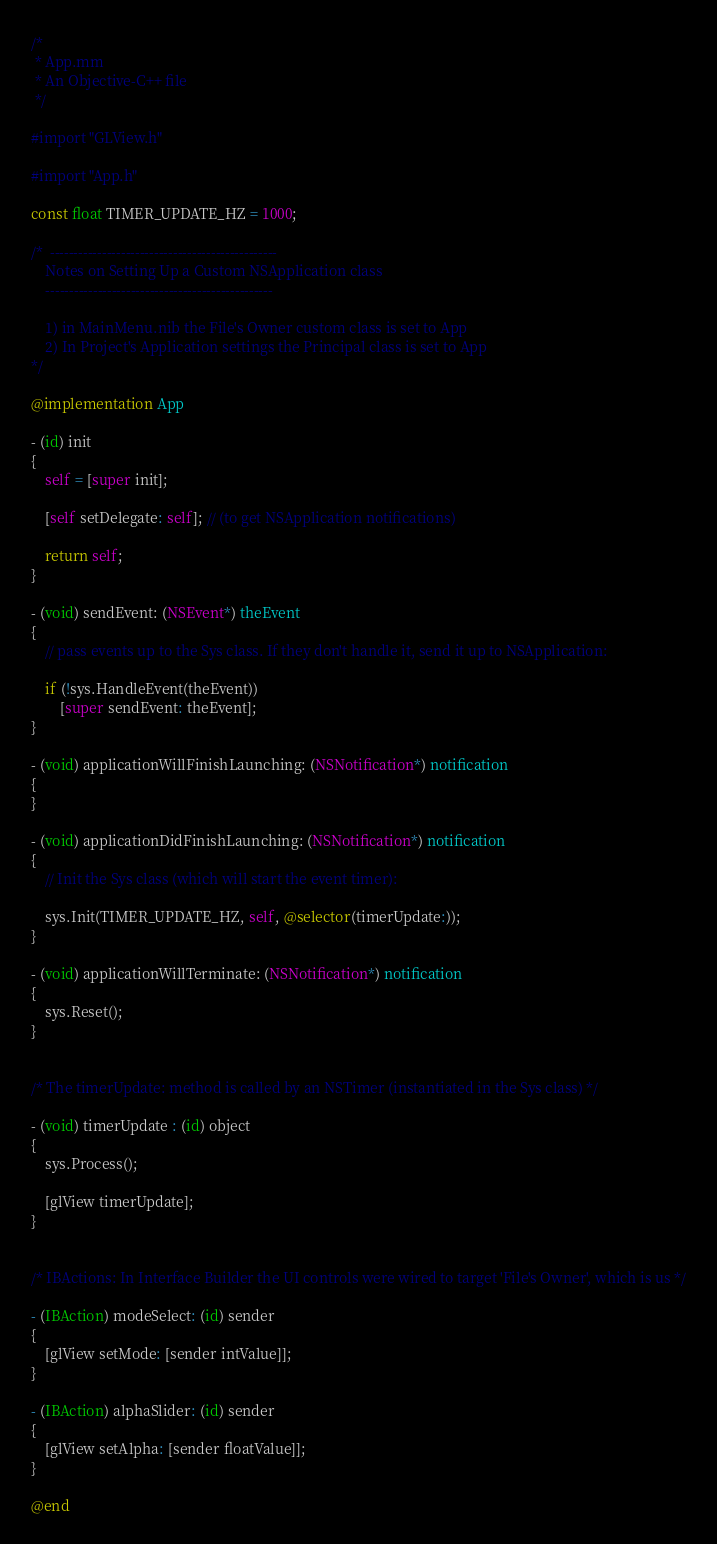Convert code to text. <code><loc_0><loc_0><loc_500><loc_500><_ObjectiveC_>/*
 * App.mm
 * An Objective-C++ file
 */

#import "GLView.h"

#import "App.h"

const float TIMER_UPDATE_HZ = 1000;

/*	------------------------------------------------
	Notes on Setting Up a Custom NSApplication class
	------------------------------------------------

	1) in MainMenu.nib the File's Owner custom class is set to App
	2) In Project's Application settings the Principal class is set to App
*/

@implementation App

- (id) init
{
	self = [super init];

	[self setDelegate: self]; // (to get NSApplication notifications)

	return self;
}

- (void) sendEvent: (NSEvent*) theEvent
{
	// pass events up to the Sys class. If they don't handle it, send it up to NSApplication:

	if (!sys.HandleEvent(theEvent))
		[super sendEvent: theEvent];
}

- (void) applicationWillFinishLaunching: (NSNotification*) notification
{
}

- (void) applicationDidFinishLaunching: (NSNotification*) notification
{
	// Init the Sys class (which will start the event timer):

	sys.Init(TIMER_UPDATE_HZ, self, @selector(timerUpdate:));
}

- (void) applicationWillTerminate: (NSNotification*) notification
{
	sys.Reset();
}


/* The timerUpdate: method is called by an NSTimer (instantiated in the Sys class) */

- (void) timerUpdate : (id) object
{
	sys.Process();

	[glView timerUpdate];
}


/* IBActions: In Interface Builder the UI controls were wired to target 'File's Owner', which is us */

- (IBAction) modeSelect: (id) sender
{
	[glView setMode: [sender intValue]];
}

- (IBAction) alphaSlider: (id) sender
{
	[glView setAlpha: [sender floatValue]];
}

@end
</code> 